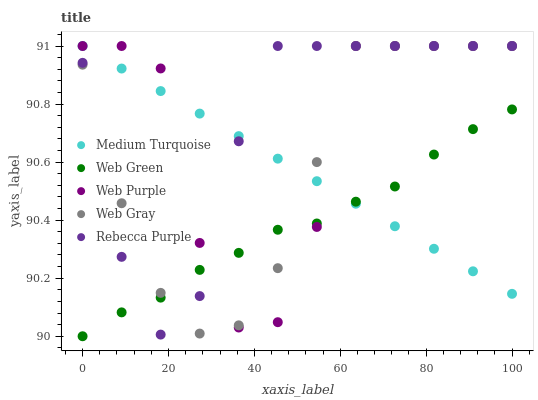Does Web Green have the minimum area under the curve?
Answer yes or no. Yes. Does Rebecca Purple have the maximum area under the curve?
Answer yes or no. Yes. Does Web Gray have the minimum area under the curve?
Answer yes or no. No. Does Web Gray have the maximum area under the curve?
Answer yes or no. No. Is Medium Turquoise the smoothest?
Answer yes or no. Yes. Is Web Purple the roughest?
Answer yes or no. Yes. Is Web Gray the smoothest?
Answer yes or no. No. Is Web Gray the roughest?
Answer yes or no. No. Does Web Green have the lowest value?
Answer yes or no. Yes. Does Web Gray have the lowest value?
Answer yes or no. No. Does Rebecca Purple have the highest value?
Answer yes or no. Yes. Does Web Green have the highest value?
Answer yes or no. No. Does Rebecca Purple intersect Web Green?
Answer yes or no. Yes. Is Rebecca Purple less than Web Green?
Answer yes or no. No. Is Rebecca Purple greater than Web Green?
Answer yes or no. No. 